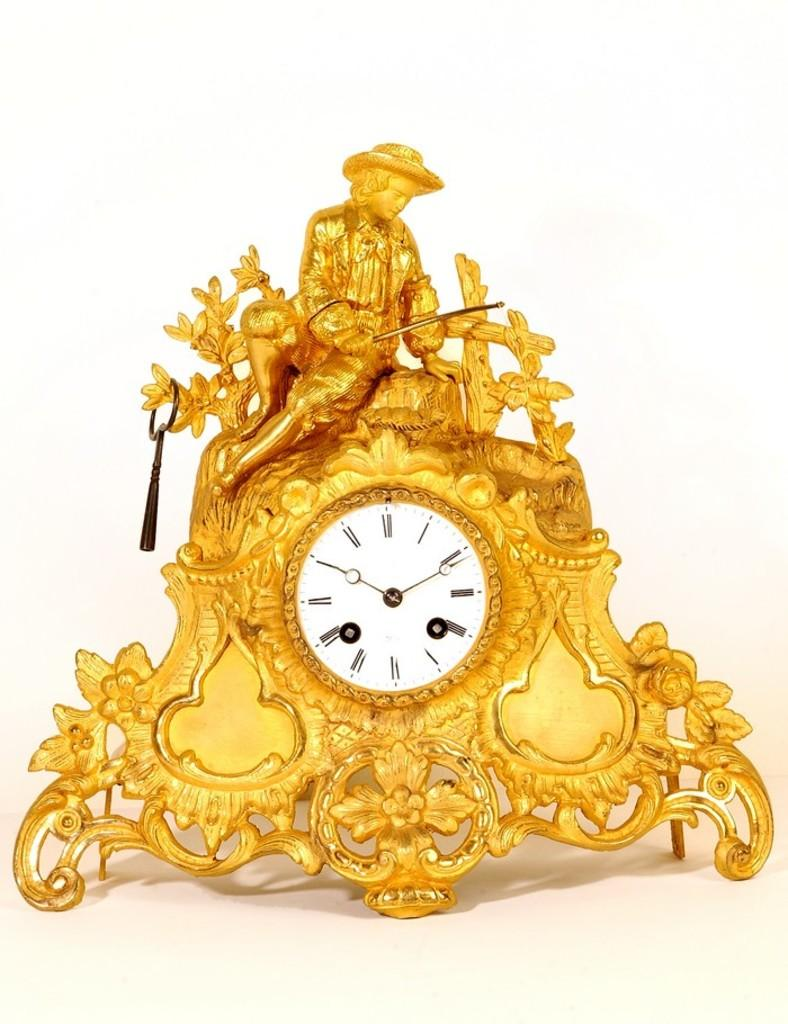<image>
Render a clear and concise summary of the photo. A gold clock with an ornate man on top set to 10:11. 